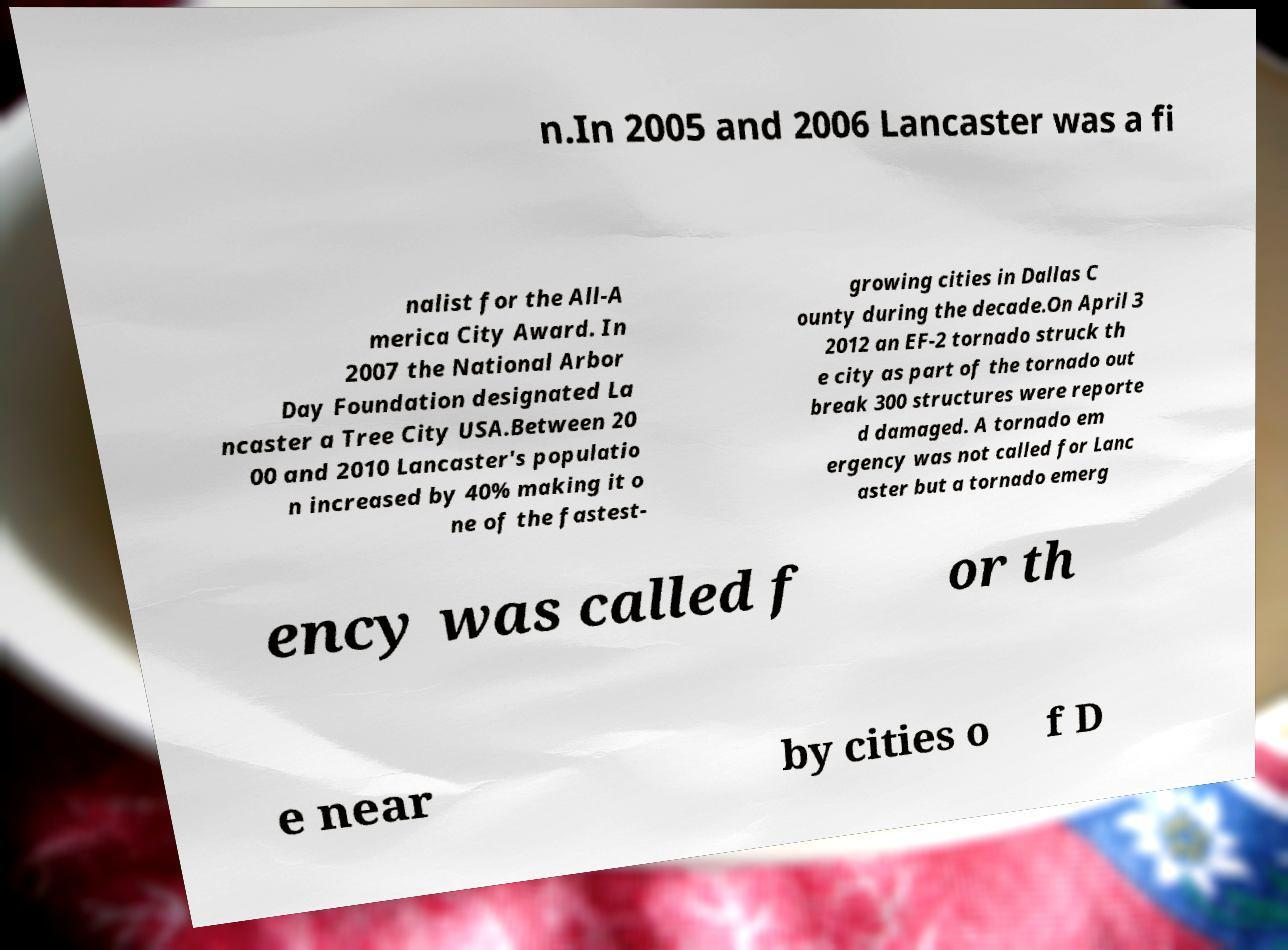I need the written content from this picture converted into text. Can you do that? n.In 2005 and 2006 Lancaster was a fi nalist for the All-A merica City Award. In 2007 the National Arbor Day Foundation designated La ncaster a Tree City USA.Between 20 00 and 2010 Lancaster's populatio n increased by 40% making it o ne of the fastest- growing cities in Dallas C ounty during the decade.On April 3 2012 an EF-2 tornado struck th e city as part of the tornado out break 300 structures were reporte d damaged. A tornado em ergency was not called for Lanc aster but a tornado emerg ency was called f or th e near by cities o f D 